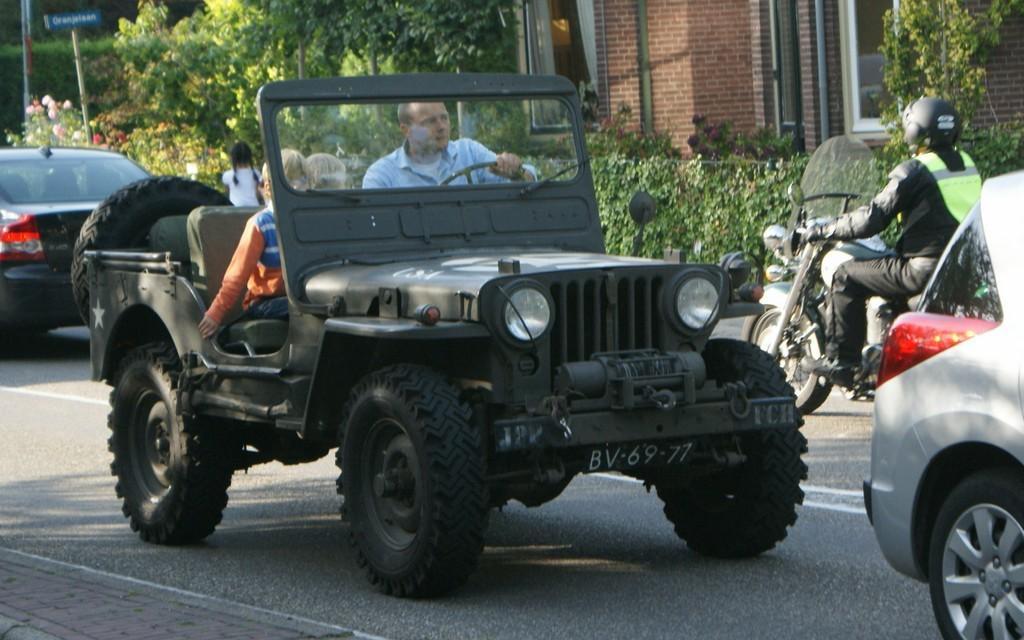In one or two sentences, can you explain what this image depicts? In this image we can see a car, motorbike, keep moving on the road. In the background of the image we can see a building and trees. 